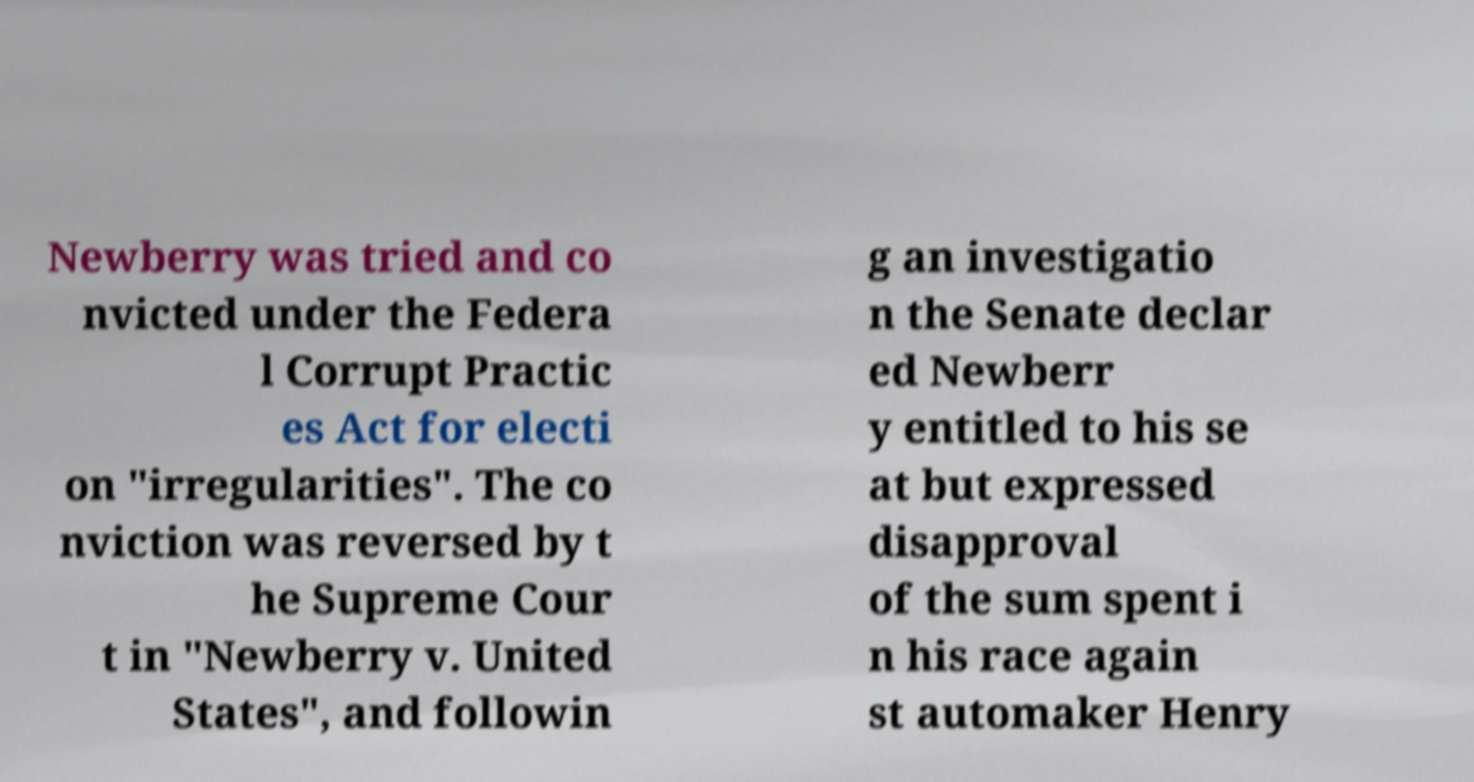Please identify and transcribe the text found in this image. Newberry was tried and co nvicted under the Federa l Corrupt Practic es Act for electi on "irregularities". The co nviction was reversed by t he Supreme Cour t in "Newberry v. United States", and followin g an investigatio n the Senate declar ed Newberr y entitled to his se at but expressed disapproval of the sum spent i n his race again st automaker Henry 